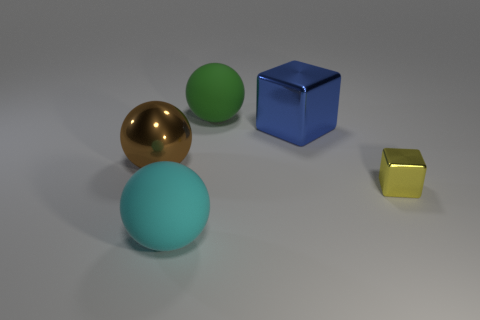Is the number of green matte balls behind the large cube greater than the number of big yellow spheres?
Offer a terse response. Yes. What is the color of the object that is to the right of the large blue shiny block?
Give a very brief answer. Yellow. Do the brown sphere and the green ball have the same size?
Offer a very short reply. Yes. What size is the blue thing?
Your response must be concise. Large. Is the number of large yellow matte cubes greater than the number of cyan matte objects?
Make the answer very short. No. There is a ball in front of the small block that is behind the big matte thing that is in front of the small thing; what is its color?
Provide a succinct answer. Cyan. There is a matte thing that is in front of the tiny yellow metallic object; is its shape the same as the blue metallic thing?
Ensure brevity in your answer.  No. What is the color of the metallic cube that is the same size as the metallic sphere?
Your response must be concise. Blue. How many big brown rubber things are there?
Give a very brief answer. 0. Is the material of the large thing that is on the right side of the large green matte sphere the same as the green object?
Ensure brevity in your answer.  No. 